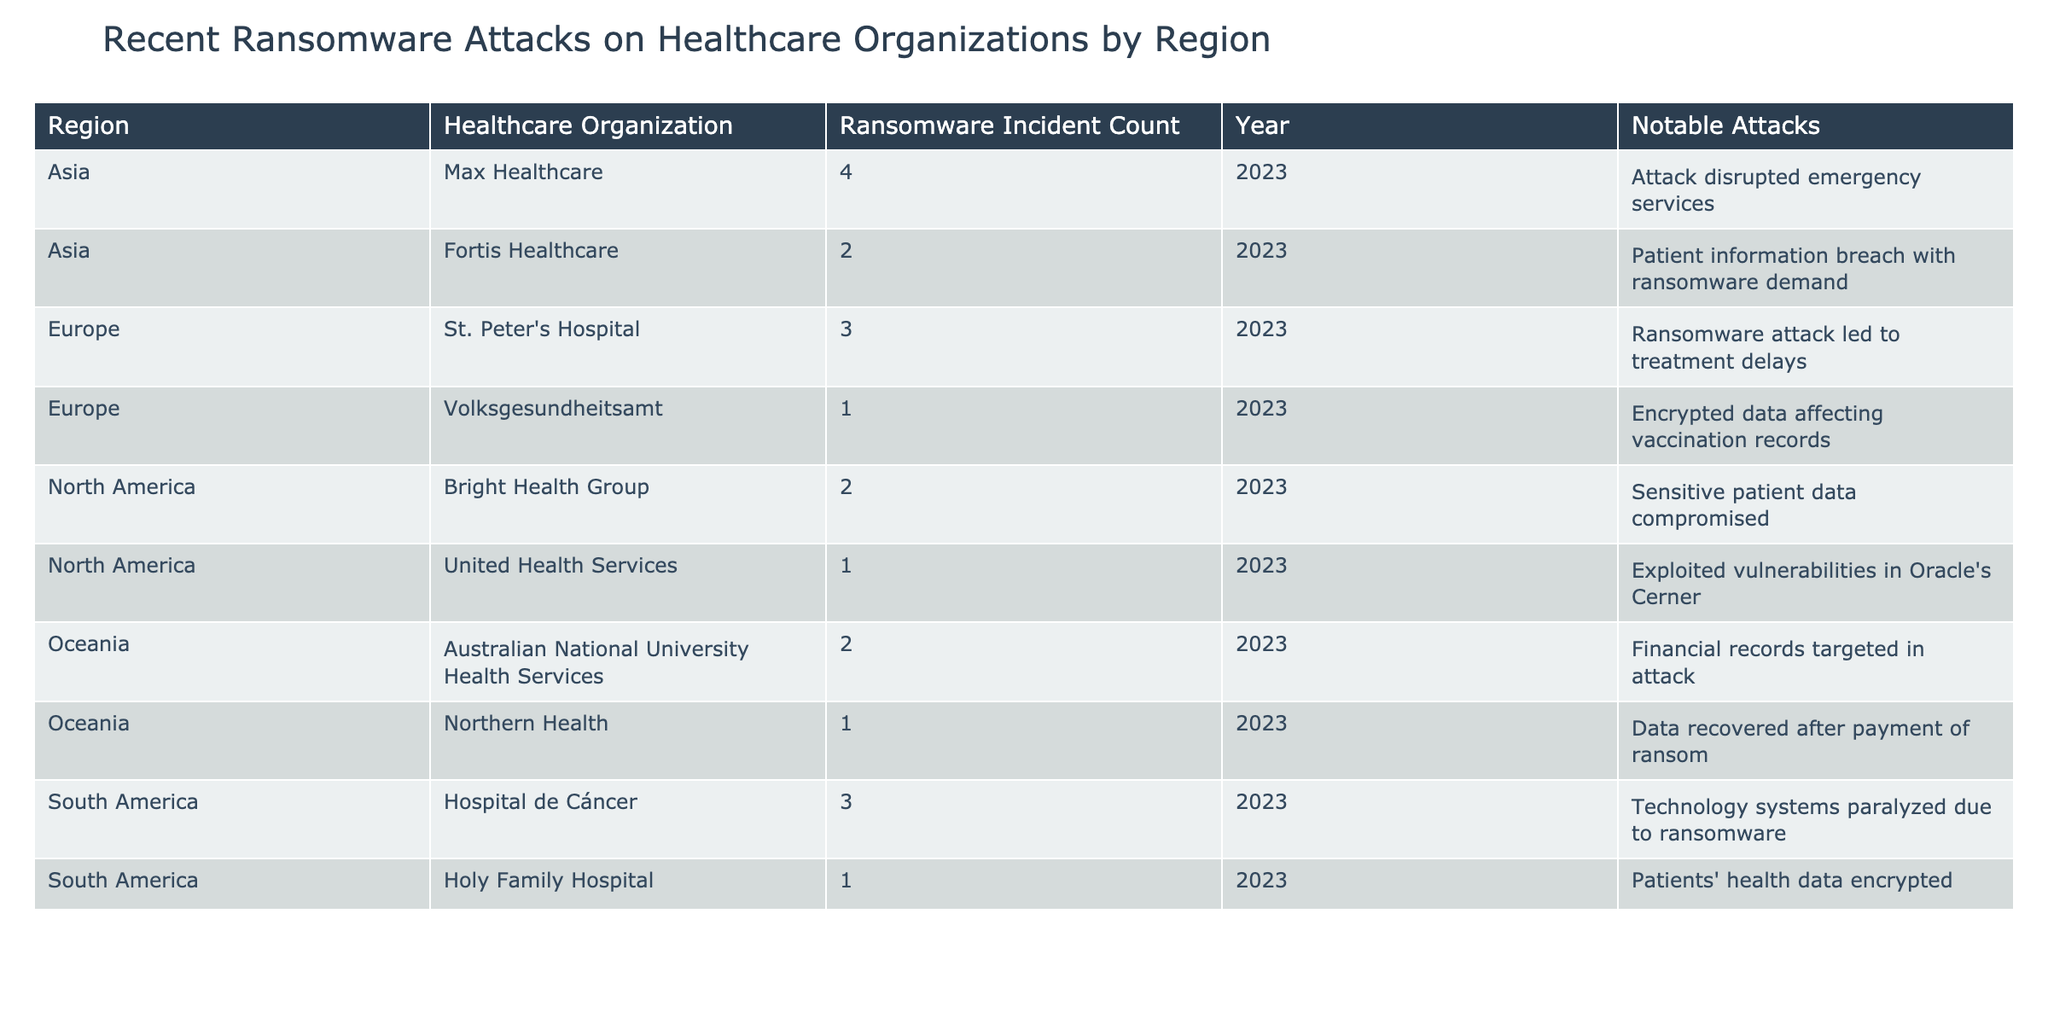What is the total number of ransomware incidents reported in North America? In the table, United Health Services reported 1 incident and Bright Health Group reported 2 incidents. Adding these together gives 1 + 2 = 3 incidents in total for North America.
Answer: 3 Which healthcare organization in Asia had the highest ransomware incident count? In the Asia region, Fortis Healthcare reported 2 incidents and Max Healthcare reported 4 incidents. Therefore, Max Healthcare has the highest incident count with 4 incidents.
Answer: Max Healthcare Was there more than one ransomware incident reported by hospitals in South America? In the table, Holy Family Hospital reported 1 incident and Hospital de Cáncer reported 3 incidents. Summing these gives 1 + 3 = 4 incidents, which is indeed more than one.
Answer: Yes Which region experienced the highest total number of ransomware incidents? Adding the ransomware incidents for each region: North America (3), Europe (4), Asia (6), South America (4), and Oceania (3). The highest total is in Asia with 6 incidents.
Answer: Asia What notable attack occurred at St. Peter's Hospital in Europe? The notable attack listed for St. Peter's Hospital is that the ransomware attack led to treatment delays.
Answer: Treatment delays How many organizations in Oceania reported ransomware incidents? The table lists Australian National University Health Services and Northern Health as two organizations in Oceania that reported incidents. Therefore, the total is 2 organizations.
Answer: 2 In which region did the most significant single ransomware incident count occur, and what was the count? Looking at the incident counts, Asia had the highest individual count with Max Healthcare reporting 4 incidents. Thus, Asia is the region with the most significant single incident count.
Answer: Asia, 4 Have there been any ransomware incidents affecting vaccination records? Yes, the table indicates that the Volksgesundheitsamt in Europe experienced an incident where data affecting vaccination records was encrypted.
Answer: Yes What is the total number of ransomware incidents reported across all regions? By summing the incidents reported from all regions: North America (3), Europe (4), Asia (6), South America (4), and Oceania (3), we get a total of 3 + 4 + 6 + 4 + 3 = 20 incidents across all regions.
Answer: 20 Which region had the fewest ransomware incidents, and what was the incident count? By comparing the incident counts of all regions, Oceania and North America both reported 3 incidents; however, Holy Family Hospital in South America reported 1 incident, which is the fewest.
Answer: South America, 1 